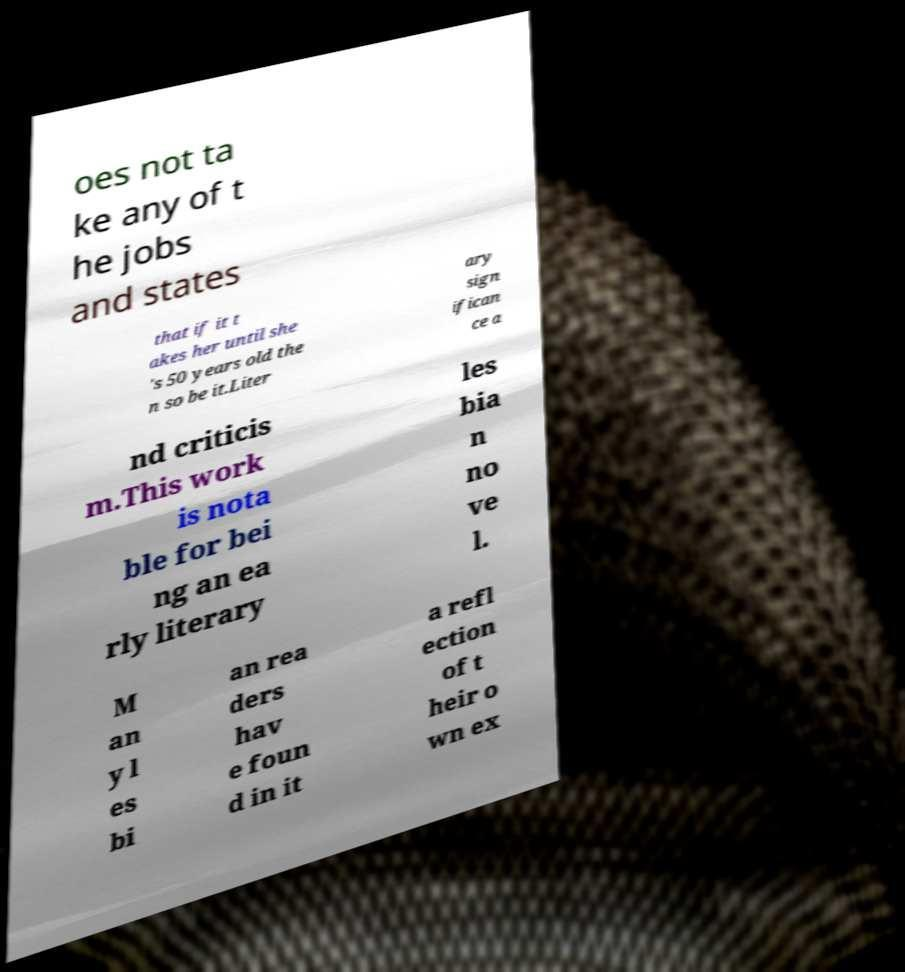Can you read and provide the text displayed in the image?This photo seems to have some interesting text. Can you extract and type it out for me? oes not ta ke any of t he jobs and states that if it t akes her until she 's 50 years old the n so be it.Liter ary sign ifican ce a nd criticis m.This work is nota ble for bei ng an ea rly literary les bia n no ve l. M an y l es bi an rea ders hav e foun d in it a refl ection of t heir o wn ex 